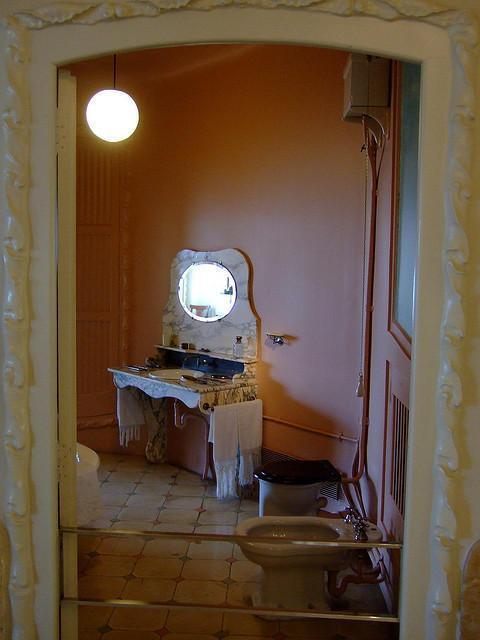How many toilets are there?
Give a very brief answer. 2. How many people are wearing a birthday hat?
Give a very brief answer. 0. 